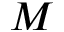<formula> <loc_0><loc_0><loc_500><loc_500>M</formula> 